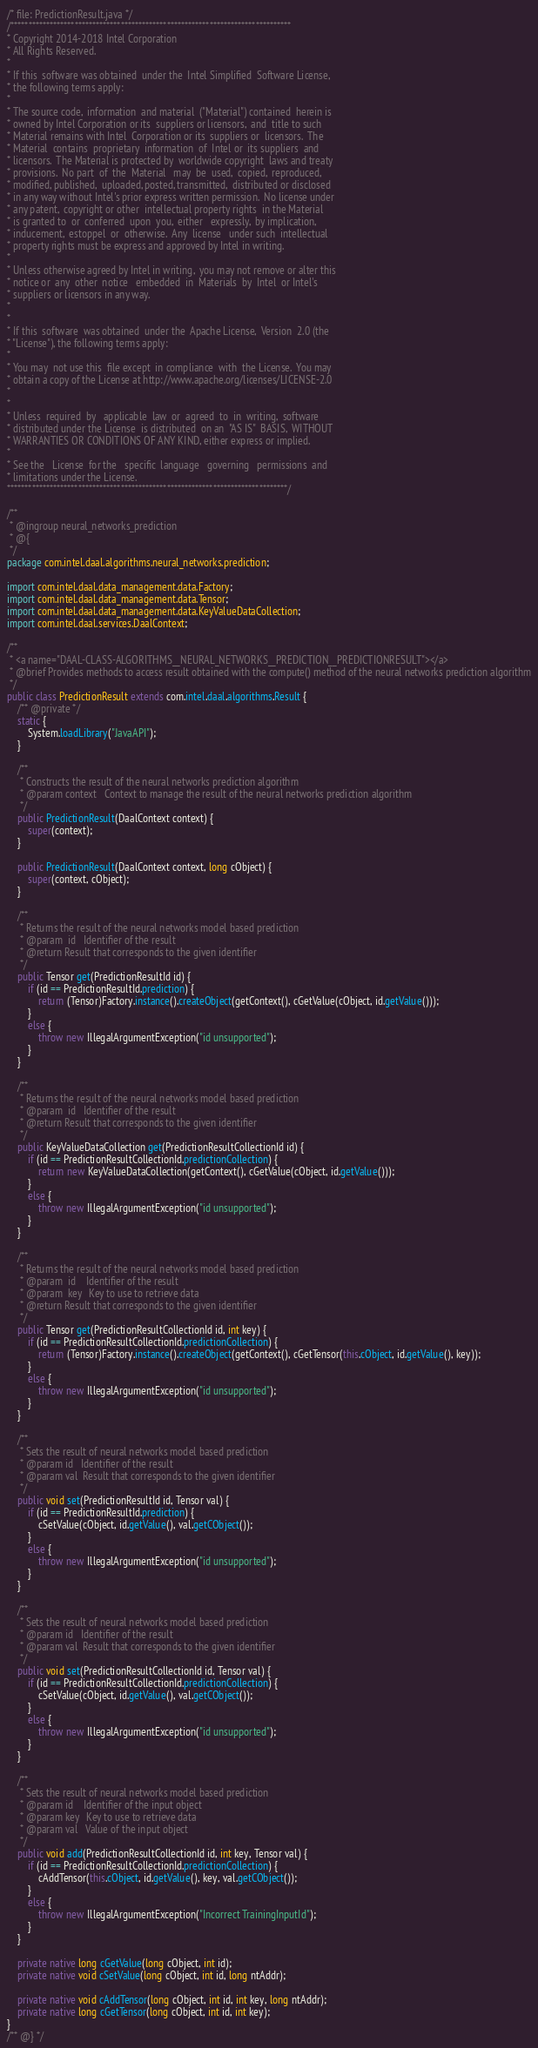Convert code to text. <code><loc_0><loc_0><loc_500><loc_500><_Java_>/* file: PredictionResult.java */
/*******************************************************************************
* Copyright 2014-2018 Intel Corporation
* All Rights Reserved.
*
* If this  software was obtained  under the  Intel Simplified  Software License,
* the following terms apply:
*
* The source code,  information  and material  ("Material") contained  herein is
* owned by Intel Corporation or its  suppliers or licensors,  and  title to such
* Material remains with Intel  Corporation or its  suppliers or  licensors.  The
* Material  contains  proprietary  information  of  Intel or  its suppliers  and
* licensors.  The Material is protected by  worldwide copyright  laws and treaty
* provisions.  No part  of  the  Material   may  be  used,  copied,  reproduced,
* modified, published,  uploaded, posted, transmitted,  distributed or disclosed
* in any way without Intel's prior express written permission.  No license under
* any patent,  copyright or other  intellectual property rights  in the Material
* is granted to  or  conferred  upon  you,  either   expressly,  by implication,
* inducement,  estoppel  or  otherwise.  Any  license   under such  intellectual
* property rights must be express and approved by Intel in writing.
*
* Unless otherwise agreed by Intel in writing,  you may not remove or alter this
* notice or  any  other  notice   embedded  in  Materials  by  Intel  or Intel's
* suppliers or licensors in any way.
*
*
* If this  software  was obtained  under the  Apache License,  Version  2.0 (the
* "License"), the following terms apply:
*
* You may  not use this  file except  in compliance  with  the License.  You may
* obtain a copy of the License at http://www.apache.org/licenses/LICENSE-2.0
*
*
* Unless  required  by   applicable  law  or  agreed  to  in  writing,  software
* distributed under the License  is distributed  on an  "AS IS"  BASIS,  WITHOUT
* WARRANTIES OR CONDITIONS OF ANY KIND, either express or implied.
*
* See the   License  for the   specific  language   governing   permissions  and
* limitations under the License.
*******************************************************************************/

/**
 * @ingroup neural_networks_prediction
 * @{
 */
package com.intel.daal.algorithms.neural_networks.prediction;

import com.intel.daal.data_management.data.Factory;
import com.intel.daal.data_management.data.Tensor;
import com.intel.daal.data_management.data.KeyValueDataCollection;
import com.intel.daal.services.DaalContext;

/**
 * <a name="DAAL-CLASS-ALGORITHMS__NEURAL_NETWORKS__PREDICTION__PREDICTIONRESULT"></a>
 * @brief Provides methods to access result obtained with the compute() method of the neural networks prediction algorithm
 */
public class PredictionResult extends com.intel.daal.algorithms.Result {
    /** @private */
    static {
        System.loadLibrary("JavaAPI");
    }

    /**
     * Constructs the result of the neural networks prediction algorithm
     * @param context   Context to manage the result of the neural networks prediction algorithm
     */
    public PredictionResult(DaalContext context) {
        super(context);
    }

    public PredictionResult(DaalContext context, long cObject) {
        super(context, cObject);
    }

    /**
     * Returns the result of the neural networks model based prediction
     * @param  id   Identifier of the result
     * @return Result that corresponds to the given identifier
     */
    public Tensor get(PredictionResultId id) {
        if (id == PredictionResultId.prediction) {
            return (Tensor)Factory.instance().createObject(getContext(), cGetValue(cObject, id.getValue()));
        }
        else {
            throw new IllegalArgumentException("id unsupported");
        }
    }

    /**
     * Returns the result of the neural networks model based prediction
     * @param  id   Identifier of the result
     * @return Result that corresponds to the given identifier
     */
    public KeyValueDataCollection get(PredictionResultCollectionId id) {
        if (id == PredictionResultCollectionId.predictionCollection) {
            return new KeyValueDataCollection(getContext(), cGetValue(cObject, id.getValue()));
        }
        else {
            throw new IllegalArgumentException("id unsupported");
        }
    }

    /**
     * Returns the result of the neural networks model based prediction
     * @param  id    Identifier of the result
     * @param  key   Key to use to retrieve data
     * @return Result that corresponds to the given identifier
     */
    public Tensor get(PredictionResultCollectionId id, int key) {
        if (id == PredictionResultCollectionId.predictionCollection) {
            return (Tensor)Factory.instance().createObject(getContext(), cGetTensor(this.cObject, id.getValue(), key));
        }
        else {
            throw new IllegalArgumentException("id unsupported");
        }
    }

    /**
     * Sets the result of neural networks model based prediction
     * @param id   Identifier of the result
     * @param val  Result that corresponds to the given identifier
     */
    public void set(PredictionResultId id, Tensor val) {
        if (id == PredictionResultId.prediction) {
            cSetValue(cObject, id.getValue(), val.getCObject());
        }
        else {
            throw new IllegalArgumentException("id unsupported");
        }
    }

    /**
     * Sets the result of neural networks model based prediction
     * @param id   Identifier of the result
     * @param val  Result that corresponds to the given identifier
     */
    public void set(PredictionResultCollectionId id, Tensor val) {
        if (id == PredictionResultCollectionId.predictionCollection) {
            cSetValue(cObject, id.getValue(), val.getCObject());
        }
        else {
            throw new IllegalArgumentException("id unsupported");
        }
    }

    /**
     * Sets the result of neural networks model based prediction
     * @param id    Identifier of the input object
     * @param key   Key to use to retrieve data
     * @param val   Value of the input object
     */
    public void add(PredictionResultCollectionId id, int key, Tensor val) {
        if (id == PredictionResultCollectionId.predictionCollection) {
            cAddTensor(this.cObject, id.getValue(), key, val.getCObject());
        }
        else {
            throw new IllegalArgumentException("Incorrect TrainingInputId");
        }
    }

    private native long cGetValue(long cObject, int id);
    private native void cSetValue(long cObject, int id, long ntAddr);

    private native void cAddTensor(long cObject, int id, int key, long ntAddr);
    private native long cGetTensor(long cObject, int id, int key);
}
/** @} */
</code> 